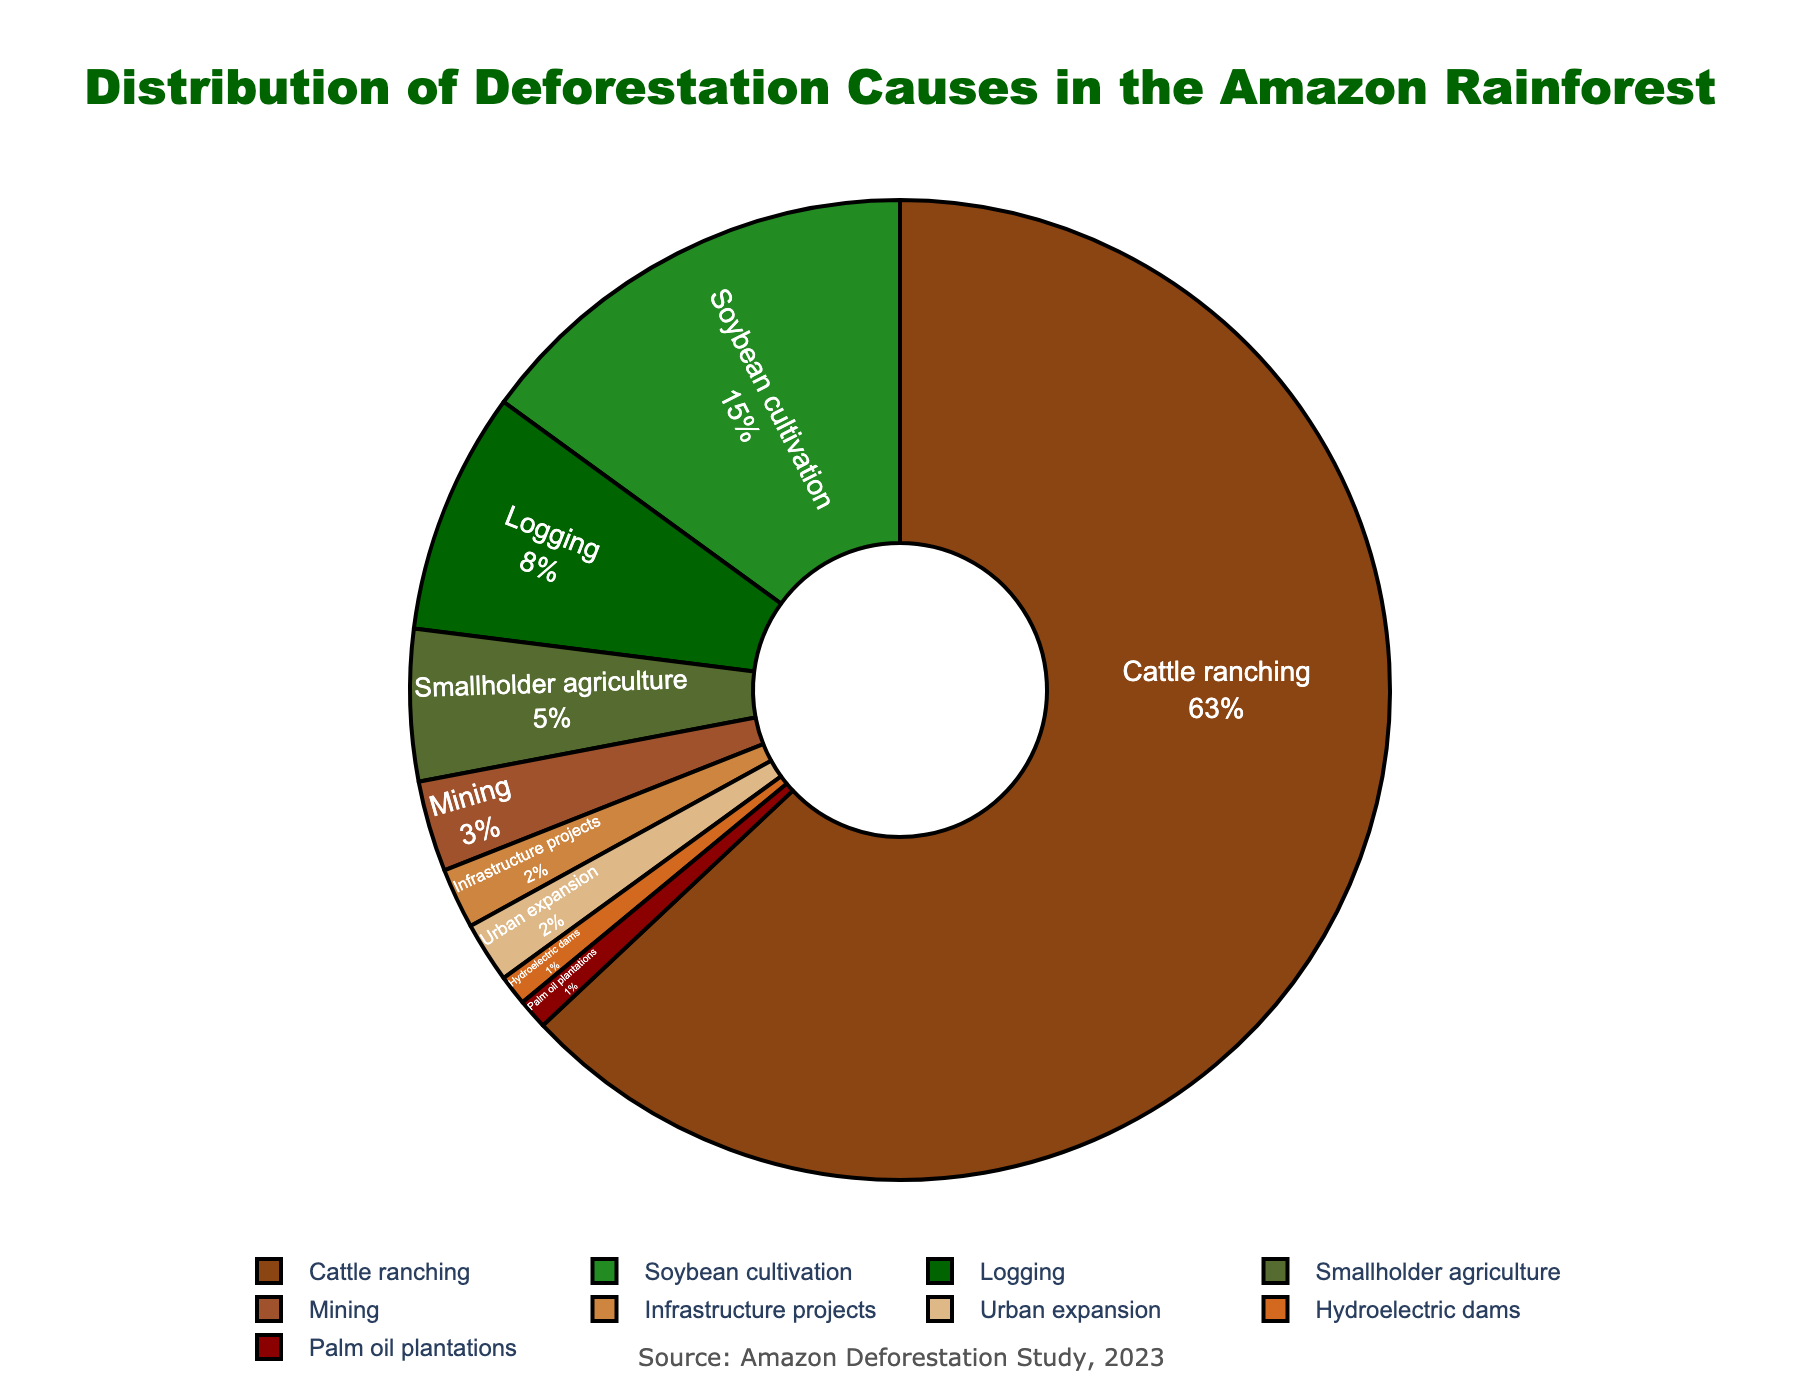what is the main cause of deforestation in the Amazon rainforest? The main cause of deforestation is illustrated by the largest segment of the pie chart, which represents cattle ranching with 63%.
Answer: Cattle ranching which two causes of deforestation have the same percentage? By observing the pie chart, we can see that urban expansion and infrastructure projects both occupy 2% of the pie chart.
Answer: Urban expansion and infrastructure projects how much greater is the percentage of deforestation caused by cattle ranching compared to soybean cultivation? The pie chart shows cattle ranching at 63% and soybean cultivation at 15%. The difference is calculated by subtracting 15% from 63%.
Answer: 48% what is the total percentage of deforestation caused by smallholder agriculture, mining, and hydroelectric dams combined? Sum the individual percentages for smallholder agriculture (5%), mining (3%), and hydroelectric dams (1%). The total is 5% + 3% + 1% = 9%.
Answer: 9% which cause of deforestation occupies the smallest section of the pie chart? The smallest section of the pie chart represents hydroelectric dams with 1%.
Answer: Hydroelectric dams compare the combined percentage of logging and smallholder agriculture to soybean cultivation. Is it more or less? how much? The combined percentage for logging (8%) and smallholder agriculture (5%) is 13%. Soybean cultivation alone is 15%. Subtract 13% from 15% to find the difference.
Answer: Less, by 2% what percentage of deforestation is caused by activities other than cattle ranching? To find this, subtract the percentage of deforestation due to cattle ranching (63%) from the total (100%).
Answer: 37% if the deforestation due to infrastructure projects were to double, what would be the new percentage? how would it compare to soybean cultivation? Doubling the percentage for infrastructure projects (2%) gives 4%. This is still less than the percentage for soybean cultivation, which is 15%.
Answer: 4%, still less which color represents the cause with the highest deforestation percentage, and what is the cause? The largest segment, which seems to be brown, represents cattle ranching, which has the highest deforestation percentage (63%).
Answer: Brown, Cattle ranching what is the total percentage share of deforestation due to agricultural activities? Agricultural activities include cattle ranching (63%), soybean cultivation (15%), palm oil plantations (1%), and smallholder agriculture (5%). The total is 63% + 15% + 1% + 5% = 84%.
Answer: 84% 